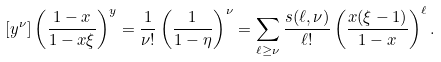<formula> <loc_0><loc_0><loc_500><loc_500>[ y ^ { \nu } ] \left ( \frac { 1 - x } { 1 - x \xi } \right ) ^ { y } & = \frac { 1 } { \nu ! } \left ( \frac { 1 } { 1 - \eta } \right ) ^ { \nu } = \sum _ { \ell \geq \nu } \frac { s ( \ell , \nu ) } { \ell ! } \left ( \frac { x ( \xi - 1 ) } { 1 - x } \right ) ^ { \ell } .</formula> 